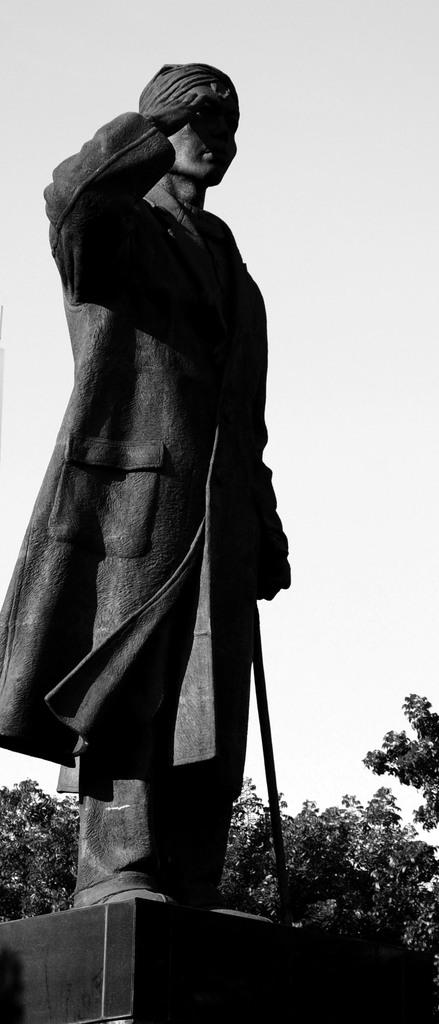What is the color scheme of the image? The image is black and white. What is the main subject of the image? There is a statue of a man in the image. How is the statue positioned in the image? The statue is placed on a pedestal. What is the statue holding in the image? The statue appears to be holding a stick. What can be seen in the background of the image? There is a sky and a tree visible in the background of the image. What type of mouth does the statue have in the image? The statue does not have a mouth, as it is a sculpture made of inanimate material. Is there a rail present in the image? There is no rail visible in the image; it only features a statue, a pedestal, and background elements. 